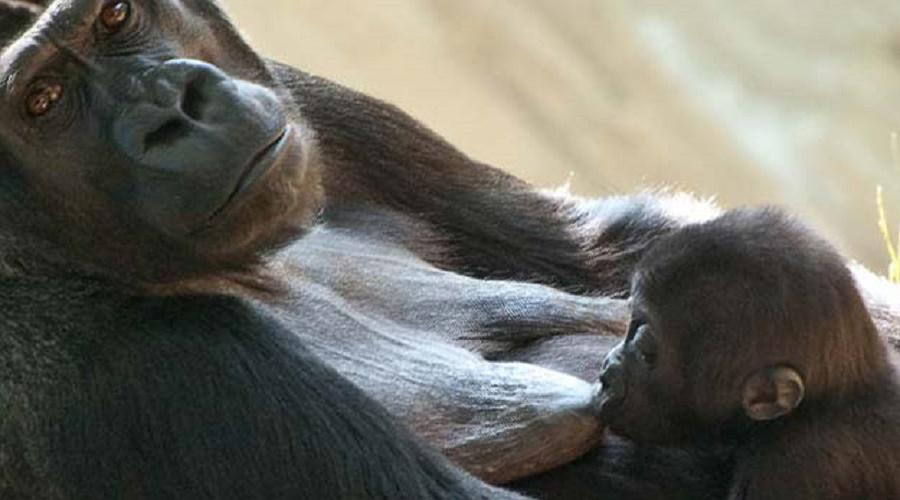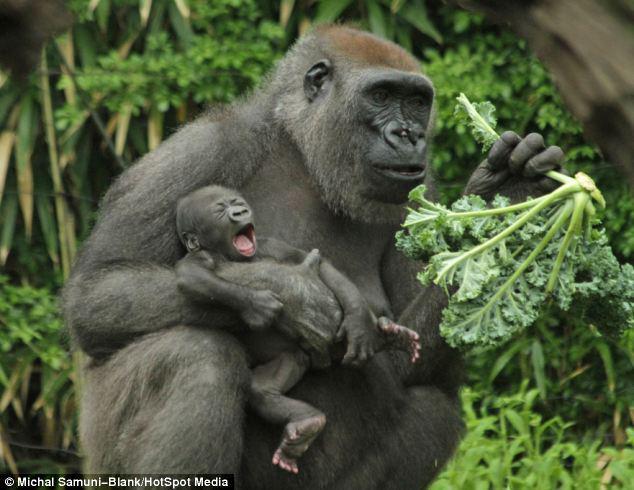The first image is the image on the left, the second image is the image on the right. Assess this claim about the two images: "a gorilla is sitting in the grass holding her infant". Correct or not? Answer yes or no. Yes. The first image is the image on the left, the second image is the image on the right. Given the left and right images, does the statement "Each image shows a baby ape nursing at its mother's breast." hold true? Answer yes or no. No. 